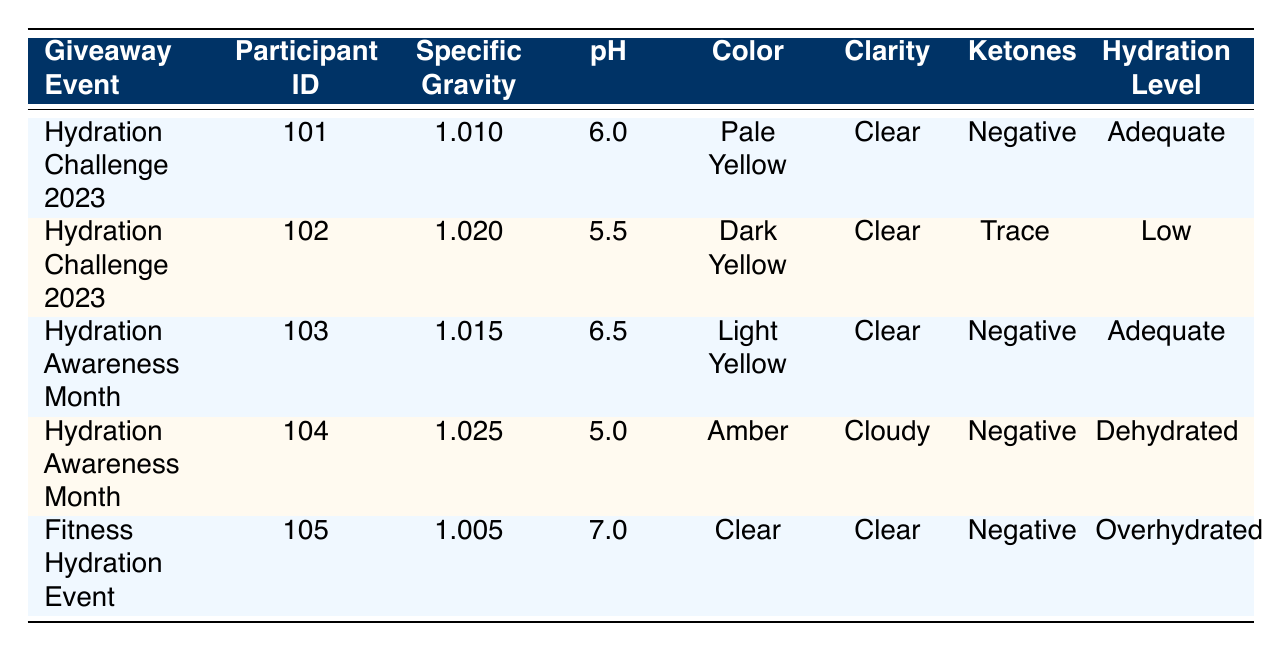What is the Specific Gravity for Participant ID 101? The Specific Gravity for Participant ID 101 is listed directly in the table under the corresponding row, which shows a value of 1.010.
Answer: 1.010 How many participants had a Hydration Level categorized as "Low"? Looking at the table, there is only one participant with a Hydration Level categorized as "Low," which is Participant ID 102.
Answer: 1 What is the pH level of the urine for the participant with the highest Specific Gravity? The highest Specific Gravity in the table is 1.025, corresponding to Participant ID 104. The pH level for this participant is 5.0, as shown in the table.
Answer: 5.0 What is the average Specific Gravity of participants labeled with "Adequate" hydration level? The participants with "Adequate" hydration levels are IDs 101 and 103, with Specific Gravities of 1.010 and 1.015 respectively. The average can be calculated by adding them: (1.010 + 1.015) / 2 = 1.0125.
Answer: 1.0125 Is there a participant who shows signs of Ketones? In the examination of the table, Participant ID 102 has 'Trace' level Ketones, which confirms that there is a participant showing signs of Ketones.
Answer: Yes What participant had the darkest urine color, and what was their hydration level? The darkest urine color noted in the table is "Dark Yellow," which belongs to Participant ID 102. Their hydration level is categorized as "Low."
Answer: Participant ID 102, Low How many participants were classified as "Dehydrated" and "Overhydrated"? There is one participant labeled as "Dehydrated" (Participant ID 104) and one labeled as "Overhydrated" (Participant ID 105) in the table, so a total of two participants fall into these categories.
Answer: 2 Which event had the most participants showing an "Adequate" hydration level? The "Hydration Challenge 2023" and "Hydration Awareness Month" events both had two participants showing "Adequate" hydration levels. Thus, both events are tied for the most participants in this category.
Answer: Both events What is the difference in pH levels between the participant with the lowest and highest pH? The lowest pH is from Participant ID 104 (5.0), and the highest pH is from Participant ID 105 (7.0). The difference is calculated as 7.0 - 5.0 = 2.0.
Answer: 2.0 